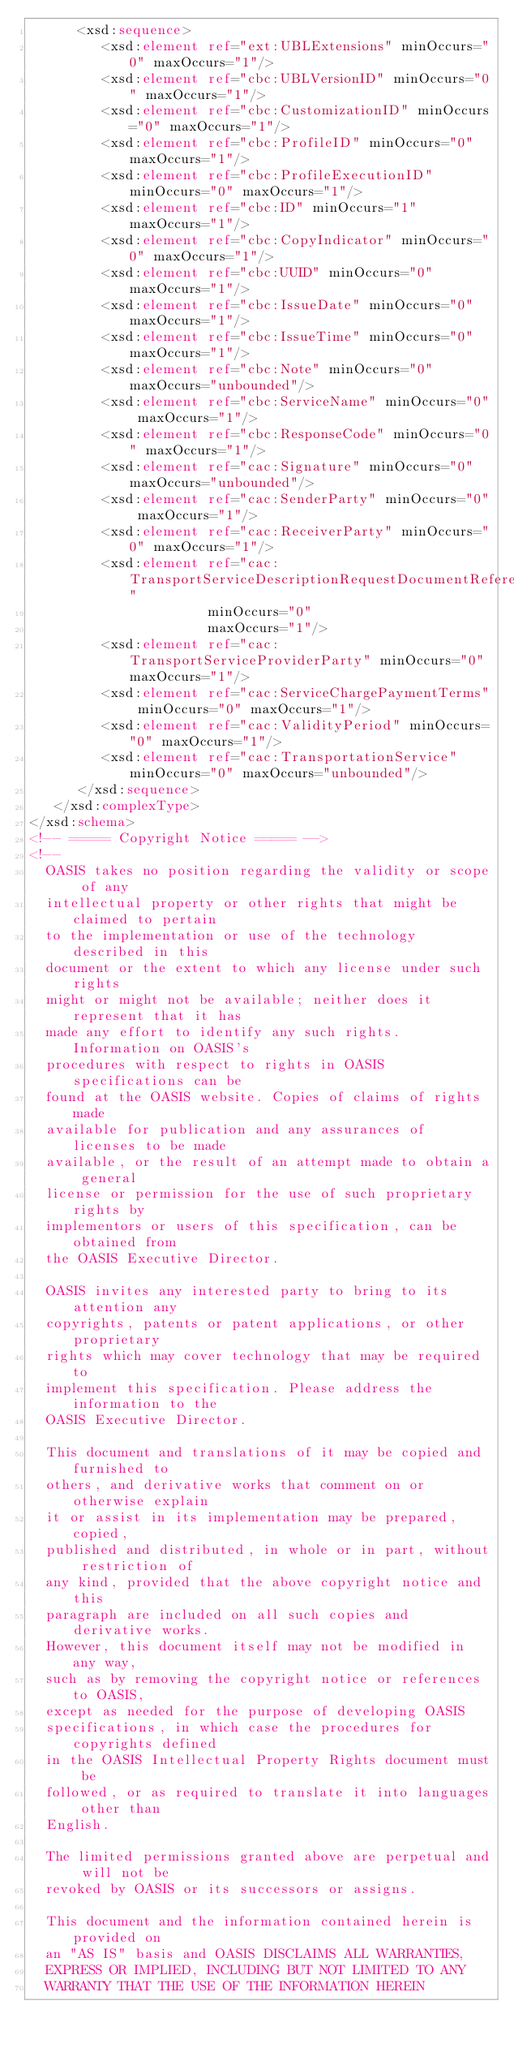Convert code to text. <code><loc_0><loc_0><loc_500><loc_500><_XML_>      <xsd:sequence>
         <xsd:element ref="ext:UBLExtensions" minOccurs="0" maxOccurs="1"/>
         <xsd:element ref="cbc:UBLVersionID" minOccurs="0" maxOccurs="1"/>
         <xsd:element ref="cbc:CustomizationID" minOccurs="0" maxOccurs="1"/>
         <xsd:element ref="cbc:ProfileID" minOccurs="0" maxOccurs="1"/>
         <xsd:element ref="cbc:ProfileExecutionID" minOccurs="0" maxOccurs="1"/>
         <xsd:element ref="cbc:ID" minOccurs="1" maxOccurs="1"/>
         <xsd:element ref="cbc:CopyIndicator" minOccurs="0" maxOccurs="1"/>
         <xsd:element ref="cbc:UUID" minOccurs="0" maxOccurs="1"/>
         <xsd:element ref="cbc:IssueDate" minOccurs="0" maxOccurs="1"/>
         <xsd:element ref="cbc:IssueTime" minOccurs="0" maxOccurs="1"/>
         <xsd:element ref="cbc:Note" minOccurs="0" maxOccurs="unbounded"/>
         <xsd:element ref="cbc:ServiceName" minOccurs="0" maxOccurs="1"/>
         <xsd:element ref="cbc:ResponseCode" minOccurs="0" maxOccurs="1"/>
         <xsd:element ref="cac:Signature" minOccurs="0" maxOccurs="unbounded"/>
         <xsd:element ref="cac:SenderParty" minOccurs="0" maxOccurs="1"/>
         <xsd:element ref="cac:ReceiverParty" minOccurs="0" maxOccurs="1"/>
         <xsd:element ref="cac:TransportServiceDescriptionRequestDocumentReference"
                      minOccurs="0"
                      maxOccurs="1"/>
         <xsd:element ref="cac:TransportServiceProviderParty" minOccurs="0" maxOccurs="1"/>
         <xsd:element ref="cac:ServiceChargePaymentTerms" minOccurs="0" maxOccurs="1"/>
         <xsd:element ref="cac:ValidityPeriod" minOccurs="0" maxOccurs="1"/>
         <xsd:element ref="cac:TransportationService" minOccurs="0" maxOccurs="unbounded"/>
      </xsd:sequence>
   </xsd:complexType>
</xsd:schema>
<!-- ===== Copyright Notice ===== -->
<!--
  OASIS takes no position regarding the validity or scope of any 
  intellectual property or other rights that might be claimed to pertain 
  to the implementation or use of the technology described in this 
  document or the extent to which any license under such rights 
  might or might not be available; neither does it represent that it has 
  made any effort to identify any such rights. Information on OASIS's 
  procedures with respect to rights in OASIS specifications can be 
  found at the OASIS website. Copies of claims of rights made 
  available for publication and any assurances of licenses to be made 
  available, or the result of an attempt made to obtain a general 
  license or permission for the use of such proprietary rights by 
  implementors or users of this specification, can be obtained from 
  the OASIS Executive Director.

  OASIS invites any interested party to bring to its attention any 
  copyrights, patents or patent applications, or other proprietary 
  rights which may cover technology that may be required to 
  implement this specification. Please address the information to the 
  OASIS Executive Director.
  
  This document and translations of it may be copied and furnished to 
  others, and derivative works that comment on or otherwise explain 
  it or assist in its implementation may be prepared, copied, 
  published and distributed, in whole or in part, without restriction of 
  any kind, provided that the above copyright notice and this 
  paragraph are included on all such copies and derivative works. 
  However, this document itself may not be modified in any way, 
  such as by removing the copyright notice or references to OASIS, 
  except as needed for the purpose of developing OASIS 
  specifications, in which case the procedures for copyrights defined 
  in the OASIS Intellectual Property Rights document must be 
  followed, or as required to translate it into languages other than 
  English. 

  The limited permissions granted above are perpetual and will not be 
  revoked by OASIS or its successors or assigns. 

  This document and the information contained herein is provided on 
  an "AS IS" basis and OASIS DISCLAIMS ALL WARRANTIES, 
  EXPRESS OR IMPLIED, INCLUDING BUT NOT LIMITED TO ANY 
  WARRANTY THAT THE USE OF THE INFORMATION HEREIN </code> 